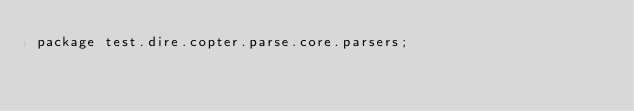<code> <loc_0><loc_0><loc_500><loc_500><_Ceylon_>package test.dire.copter.parse.core.parsers;
</code> 